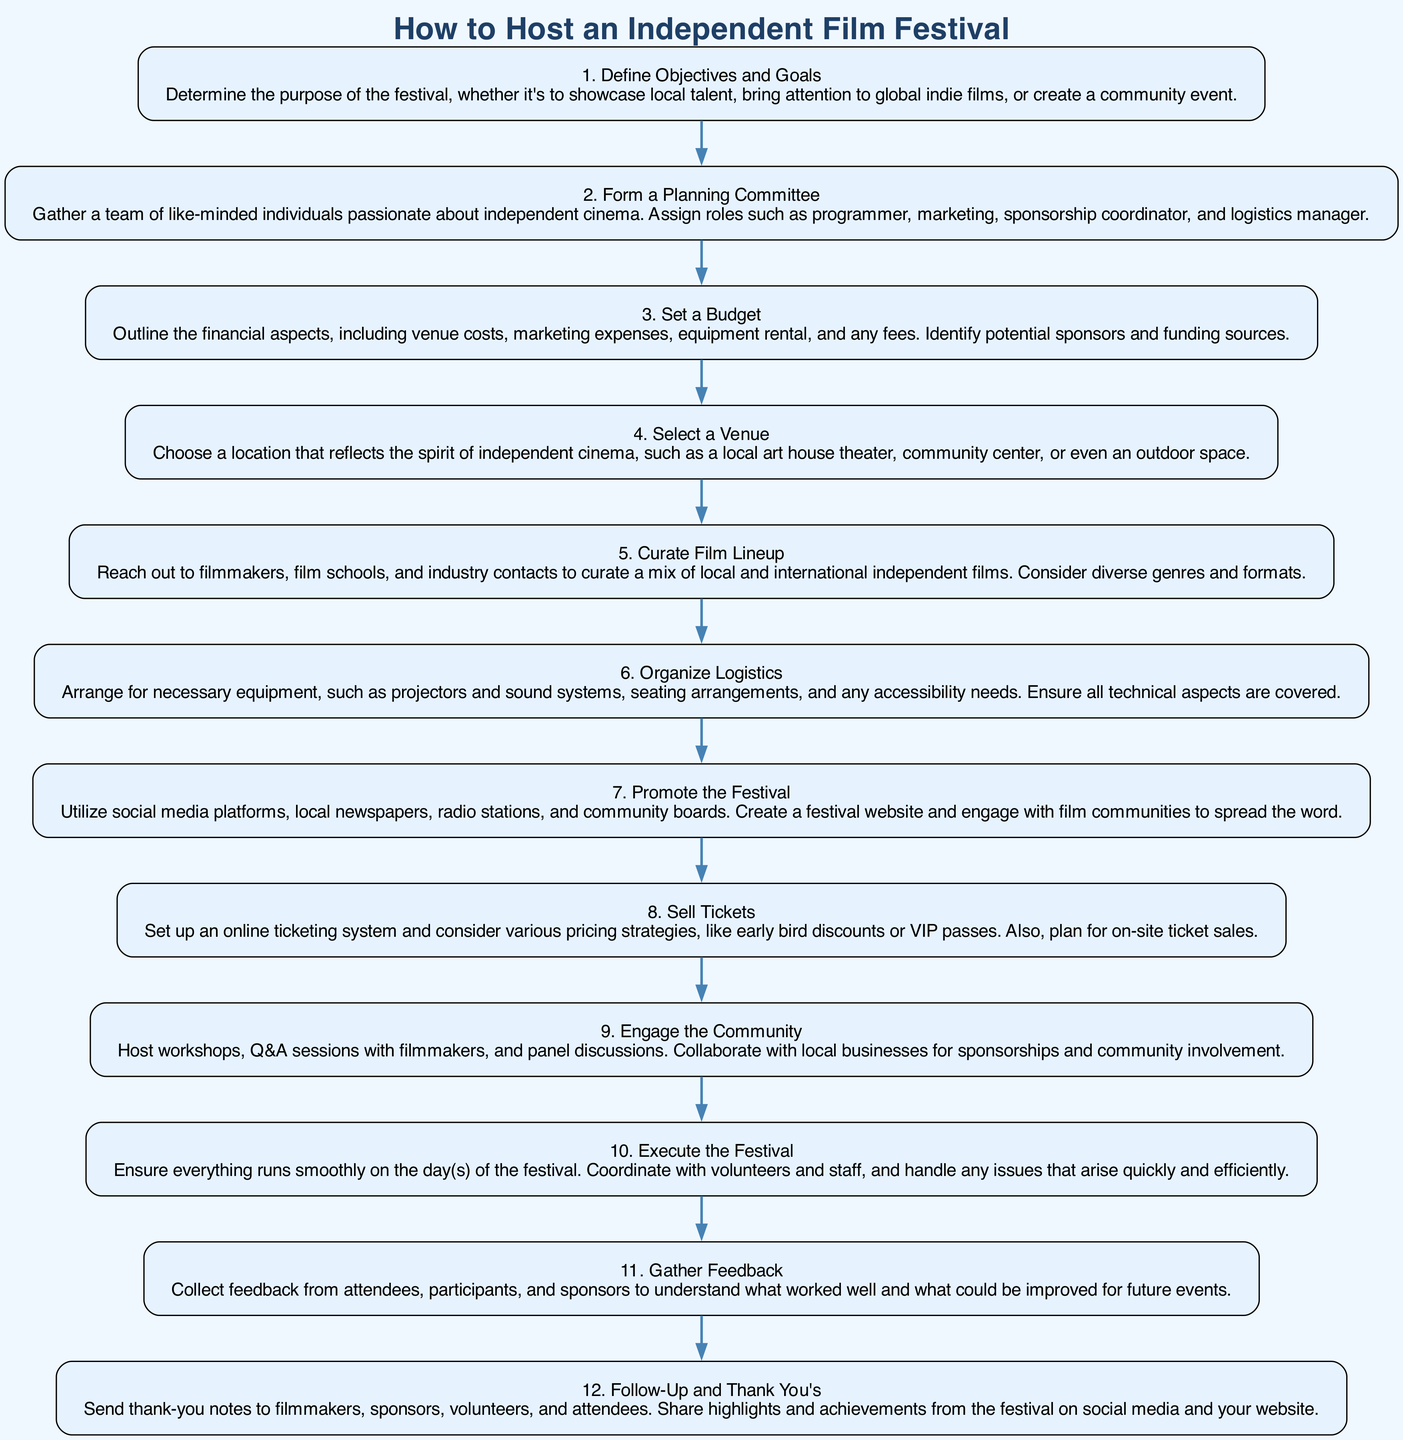What is the first step in the diagram? The diagram starts with "Define Objectives and Goals," which is the first node listed.
Answer: Define Objectives and Goals How many total steps are in the diagram? By counting the nodes listed in the flow chart, there are eleven distinct steps from start to finish.
Answer: Eleven What is the last step in the flow chart? The final node in the sequence is "Follow-Up and Thank You's," representing the closing actions after the festival.
Answer: Follow-Up and Thank You's Which step involves community workshops? The step "Engage the Community" specifically mentions hosting workshops as part of its activities.
Answer: Engage the Community What is the main purpose of the "Set a Budget" step? The "Set a Budget" step includes outlining financial aspects such as venue costs and identifying potential funding sources, crucial for overall planning.
Answer: Outline financial aspects Which two steps directly precede the "Execute the Festival" step? The two preceding steps are "Organize Logistics" and "Promote the Festival." These establish necessary preparations before execution.
Answer: Organize Logistics and Promote the Festival What two activities are included in the “Engage the Community” step? The activities mentioned in this step are hosting workshops and Q&A sessions with filmmakers, which foster community involvement.
Answer: Workshops and Q&A sessions What is needed to be arranged in the "Organize Logistics" step? This step emphasizes the arrangement of necessary equipment like projectors, sound systems, and seating arrangements to ensure the event runs smoothly.
Answer: Necessary equipment What does the "Gather Feedback" step focus on? This step is centered on collecting feedback from attendees, participants, and sponsors to evaluate the festival's success and areas of improvement.
Answer: Collect feedback 